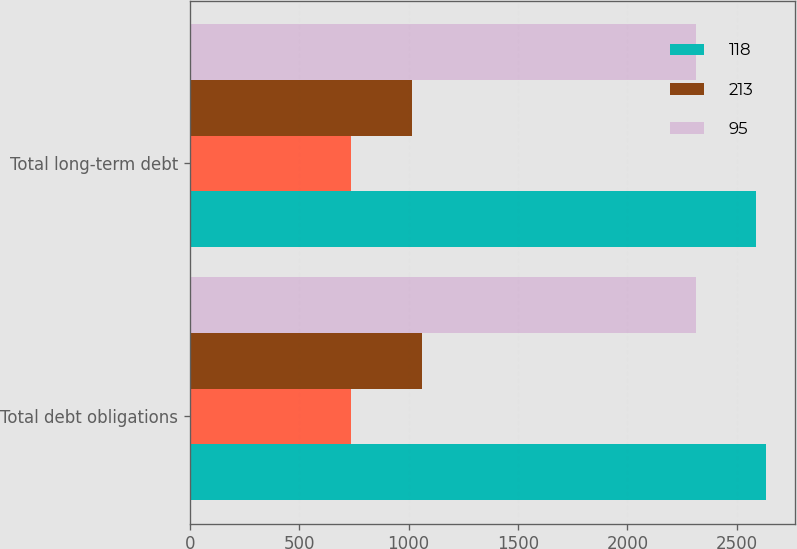<chart> <loc_0><loc_0><loc_500><loc_500><stacked_bar_chart><ecel><fcel>Total debt obligations<fcel>Total long-term debt<nl><fcel>118<fcel>2634<fcel>2589<nl><fcel>nan<fcel>739<fcel>739<nl><fcel>213<fcel>1060<fcel>1015<nl><fcel>95<fcel>2313<fcel>2313<nl></chart> 